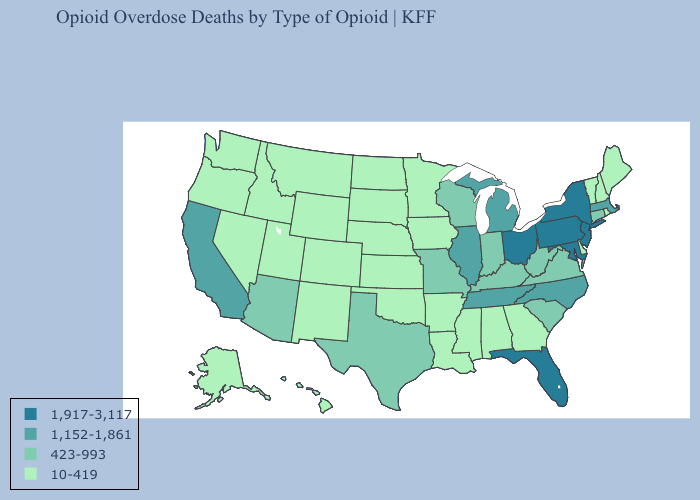Does the first symbol in the legend represent the smallest category?
Quick response, please. No. Does Iowa have the highest value in the USA?
Short answer required. No. Name the states that have a value in the range 10-419?
Keep it brief. Alabama, Alaska, Arkansas, Colorado, Delaware, Georgia, Hawaii, Idaho, Iowa, Kansas, Louisiana, Maine, Minnesota, Mississippi, Montana, Nebraska, Nevada, New Hampshire, New Mexico, North Dakota, Oklahoma, Oregon, Rhode Island, South Dakota, Utah, Vermont, Washington, Wyoming. What is the highest value in states that border Illinois?
Short answer required. 423-993. What is the value of Oregon?
Short answer required. 10-419. Is the legend a continuous bar?
Quick response, please. No. What is the value of Delaware?
Short answer required. 10-419. Name the states that have a value in the range 1,152-1,861?
Keep it brief. California, Illinois, Massachusetts, Michigan, North Carolina, Tennessee. Name the states that have a value in the range 1,917-3,117?
Concise answer only. Florida, Maryland, New Jersey, New York, Ohio, Pennsylvania. What is the value of Rhode Island?
Be succinct. 10-419. Which states have the lowest value in the USA?
Write a very short answer. Alabama, Alaska, Arkansas, Colorado, Delaware, Georgia, Hawaii, Idaho, Iowa, Kansas, Louisiana, Maine, Minnesota, Mississippi, Montana, Nebraska, Nevada, New Hampshire, New Mexico, North Dakota, Oklahoma, Oregon, Rhode Island, South Dakota, Utah, Vermont, Washington, Wyoming. What is the value of Colorado?
Answer briefly. 10-419. What is the highest value in the West ?
Concise answer only. 1,152-1,861. Does Montana have the lowest value in the West?
Keep it brief. Yes. 